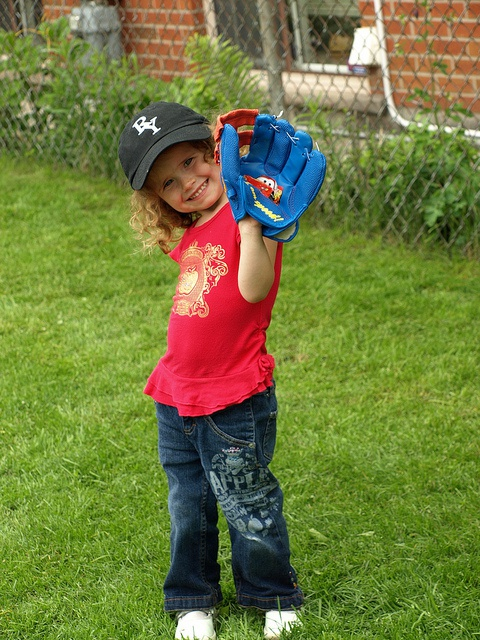Describe the objects in this image and their specific colors. I can see people in black, brown, red, and gray tones and baseball glove in black, blue, navy, and gray tones in this image. 